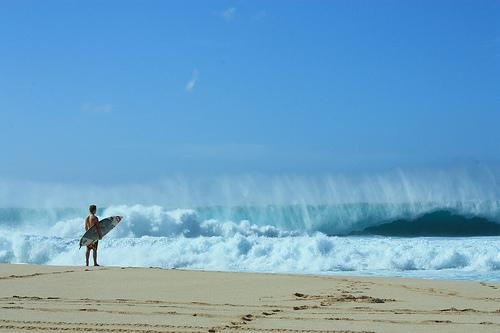Question: what is the man holding?
Choices:
A. Sunglasses.
B. Surfboard.
C. Kite.
D. Frisbee.
Answer with the letter. Answer: B Question: how many men are in the photo?
Choices:
A. Three.
B. Two.
C. Four.
D. One.
Answer with the letter. Answer: D Question: what is the man looking at?
Choices:
A. Lake.
B. Pond.
C. Ocean.
D. Stream.
Answer with the letter. Answer: C Question: what is the man standing on?
Choices:
A. Dirt.
B. Grass.
C. Sidewalk.
D. Sand.
Answer with the letter. Answer: D Question: where is the photo taken?
Choices:
A. Beach.
B. Ocean.
C. Lake.
D. Pond.
Answer with the letter. Answer: A Question: what color is the sand?
Choices:
A. Tan.
B. Black.
C. Yellow.
D. White.
Answer with the letter. Answer: A 